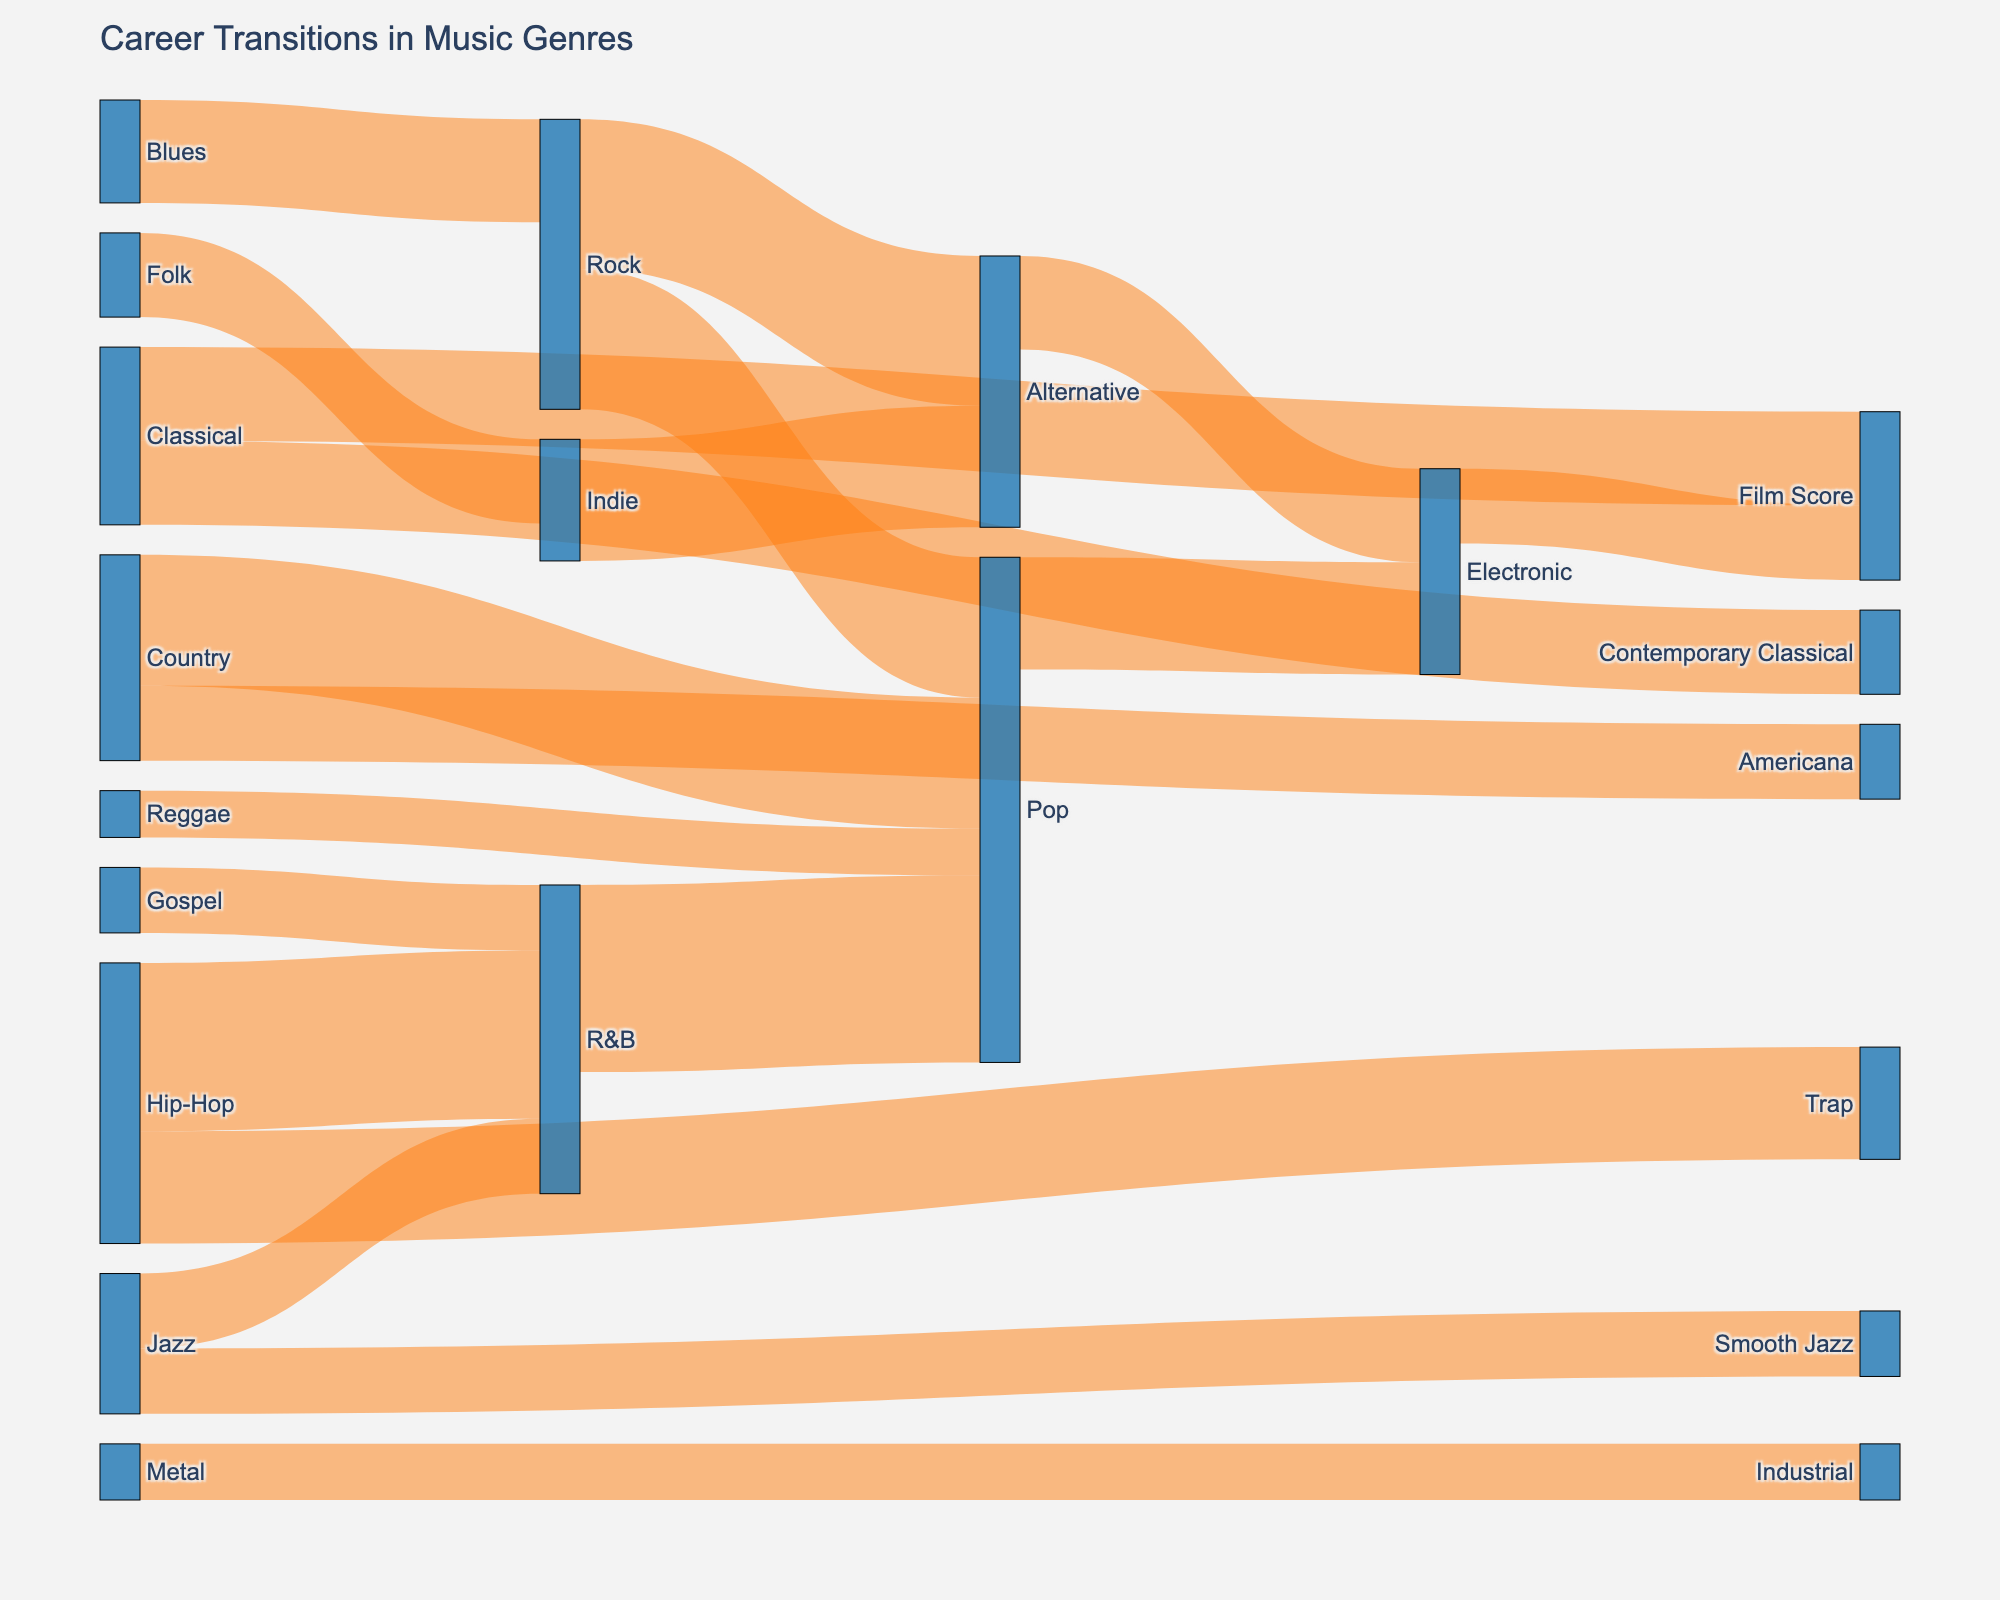What is the title of the Sankey diagram? The title of the Sankey diagram is usually located at the top of the figure in a larger font size. By referring to the top of the figure, you can find the title text.
Answer: Career Transitions in Music Genres How many musicians transitioned from Hip-Hop to R&B? To find this, locate the flow from Hip-Hop to R&B in the Sankey diagram and check the value associated with this connection.
Answer: 18 Which genre transitions to Pop the most frequently? By identifying all the flows directed towards Pop and comparing their values, we can determine which source genre has the highest flow to Pop. Check the connections from Rock, R&B, Country, Reggae, and other genres to Pop.
Answer: R&B What is the total number of transitions into the Pop genre? Add up all the values of the flows that target Pop: 15 (Rock to Pop) + 20 (R&B to Pop) + 14 (Country to Pop) + 5 (Reggae to Pop). This gives the total number of transitions into Pop.
Answer: 54 Which genre has the highest number of distinct target genres for transitions? Count the number of different target genres connected from each source genre. The genre with the most distinct target connections has the highest number.
Answer: Rock (3 targets: Pop, Alternative, and Indie) How many genre transitions involve Electronic music, either as a source or target? To find this, identify all connections involving Electronic music and sum their values: 12 (Pop to Electronic) + 10 (Alternative to Electronic) + 8 (Electronic to Film Score).
Answer: 30 What is the total value of transitions originating from Classical music? Sum the values of all transitions where Classical is the source: 10 (Classical to Film Score) + 9 (Classical to Contemporary Classical).
Answer: 19 Which transition has the lowest value, and what is it? Look for the smallest value among all the flows in the Sankey diagram.
Answer: Metal to Industrial Between Jazz to R&B and Hip-Hop to Trap, which transition has a higher value? Compare the values of the two transitions. Jazz to R&B has a value of 8, and Hip-Hop to Trap has a value of 12.
Answer: Hip-Hop to Trap 